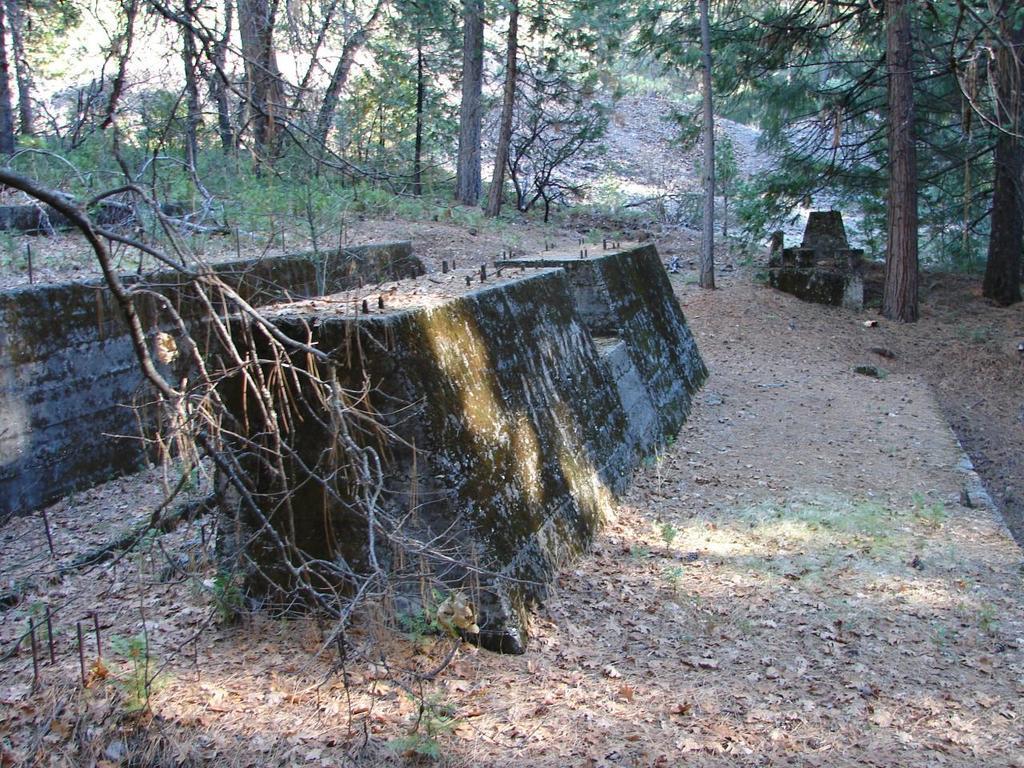Please provide a concise description of this image. In this image there are concrete blocks and there are trees. 